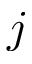<formula> <loc_0><loc_0><loc_500><loc_500>j</formula> 